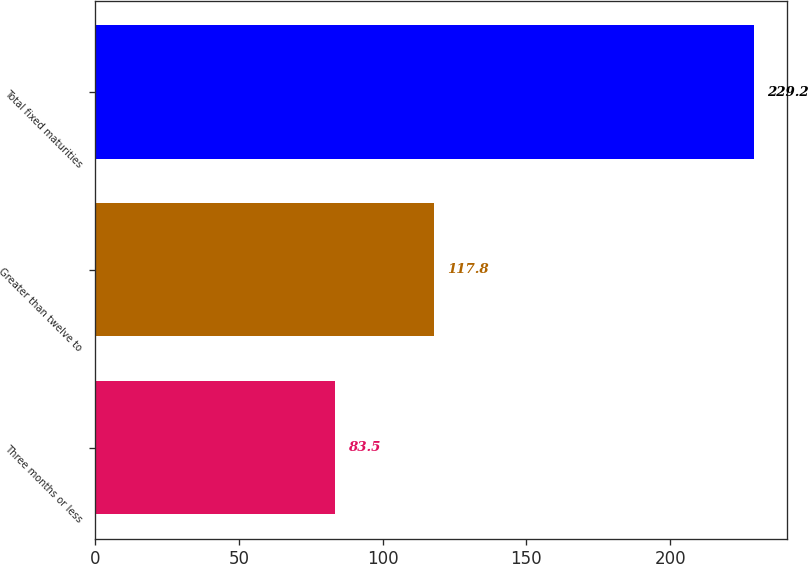Convert chart to OTSL. <chart><loc_0><loc_0><loc_500><loc_500><bar_chart><fcel>Three months or less<fcel>Greater than twelve to<fcel>Total fixed maturities<nl><fcel>83.5<fcel>117.8<fcel>229.2<nl></chart> 